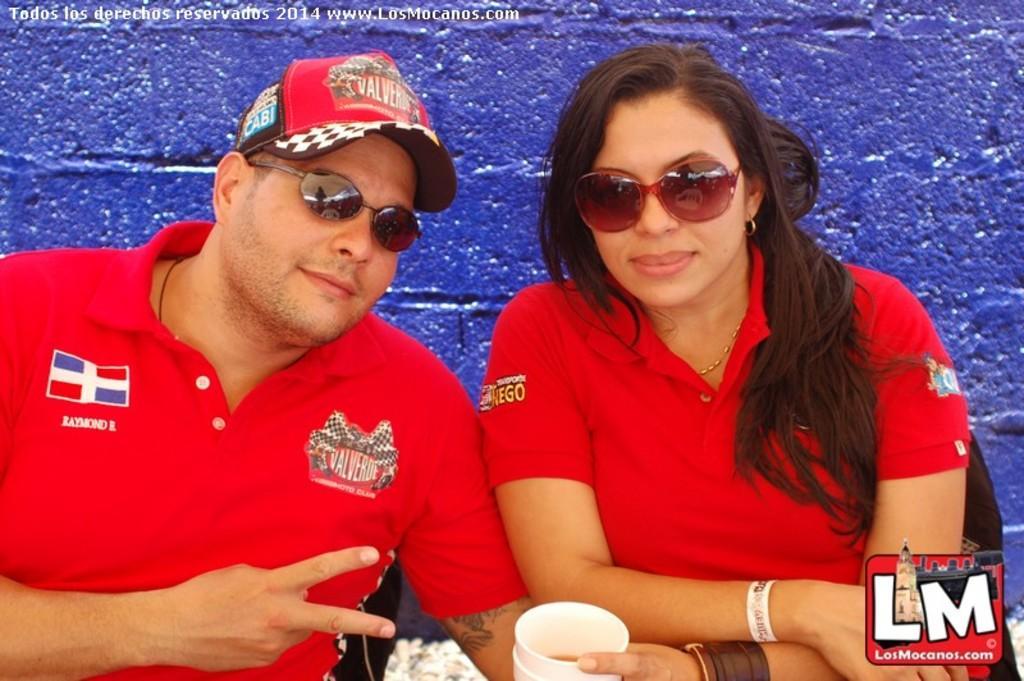How would you summarize this image in a sentence or two? In this image we can see a woman holding a glass in her hand and a person is sitting on chairs At the top of the image we can see the wall. 